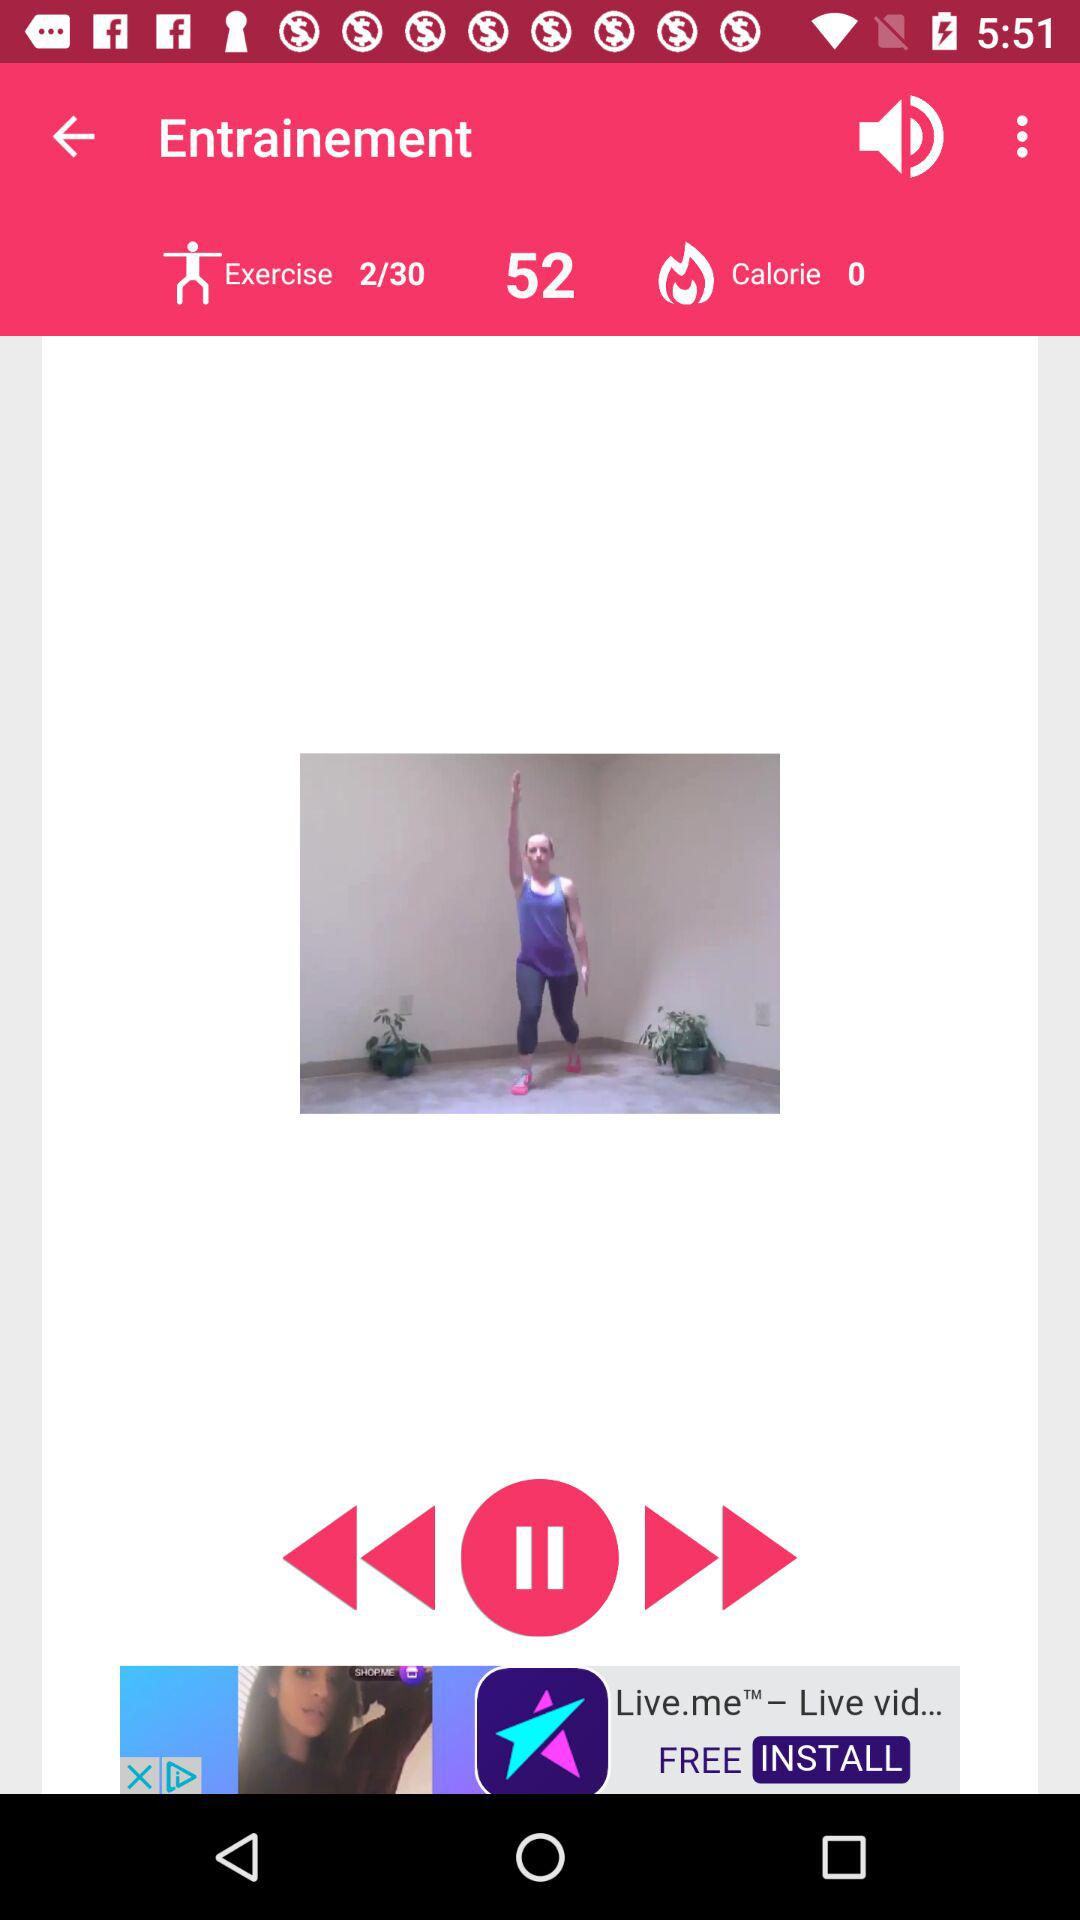How many more exercises do I have to complete to finish this workout?
Answer the question using a single word or phrase. 28 